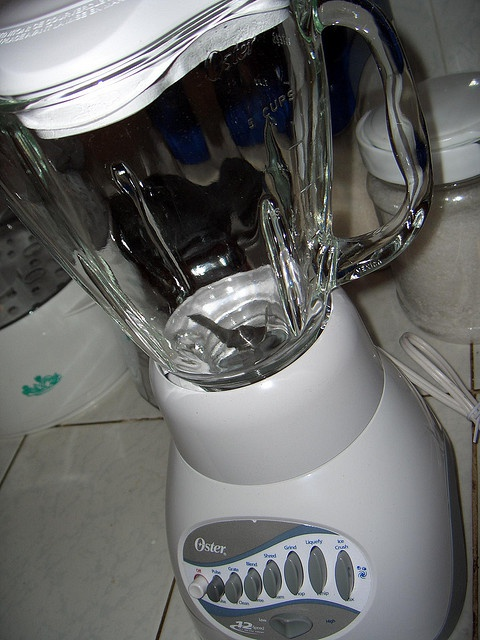Describe the objects in this image and their specific colors. I can see various objects in this image with different colors. 